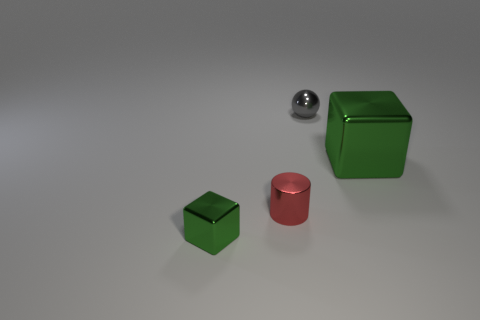Do the object on the left side of the tiny metallic cylinder and the block behind the small green shiny thing have the same color?
Your answer should be compact. Yes. What number of cubes are green metal things or small metal objects?
Make the answer very short. 2. Are there an equal number of gray things to the right of the large shiny thing and red objects?
Provide a succinct answer. No. There is a thing that is behind the green shiny object right of the green block that is to the left of the gray ball; what is its material?
Give a very brief answer. Metal. There is a thing that is the same color as the large metallic cube; what is it made of?
Provide a short and direct response. Metal. What number of objects are tiny metal things that are left of the tiny red cylinder or tiny purple metal blocks?
Ensure brevity in your answer.  1. What number of objects are big purple rubber blocks or large green cubes that are behind the small green cube?
Your response must be concise. 1. What number of metallic blocks are in front of the green cube that is behind the block that is left of the big green shiny thing?
Offer a very short reply. 1. There is a gray sphere that is the same size as the cylinder; what is its material?
Offer a terse response. Metal. Are there any shiny blocks of the same size as the red cylinder?
Your answer should be compact. Yes. 